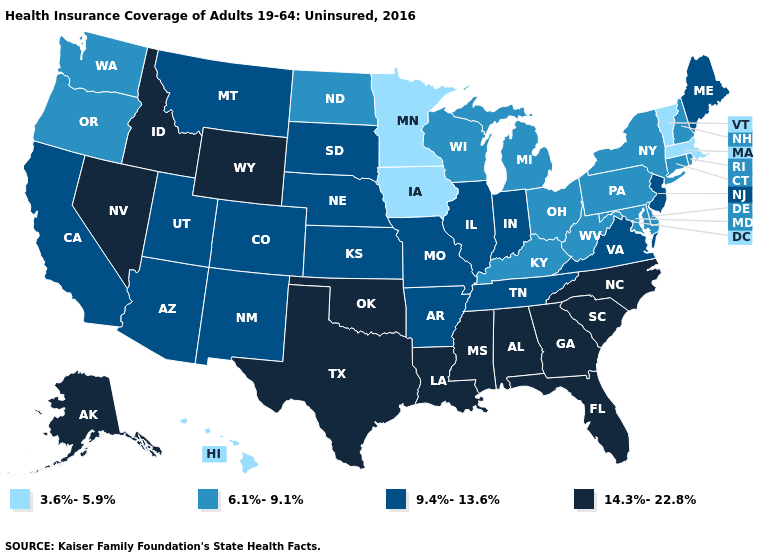What is the lowest value in the Northeast?
Give a very brief answer. 3.6%-5.9%. Name the states that have a value in the range 3.6%-5.9%?
Be succinct. Hawaii, Iowa, Massachusetts, Minnesota, Vermont. Name the states that have a value in the range 6.1%-9.1%?
Short answer required. Connecticut, Delaware, Kentucky, Maryland, Michigan, New Hampshire, New York, North Dakota, Ohio, Oregon, Pennsylvania, Rhode Island, Washington, West Virginia, Wisconsin. Is the legend a continuous bar?
Concise answer only. No. Name the states that have a value in the range 9.4%-13.6%?
Concise answer only. Arizona, Arkansas, California, Colorado, Illinois, Indiana, Kansas, Maine, Missouri, Montana, Nebraska, New Jersey, New Mexico, South Dakota, Tennessee, Utah, Virginia. What is the value of Maryland?
Answer briefly. 6.1%-9.1%. Does Georgia have a lower value than New Mexico?
Be succinct. No. What is the highest value in the USA?
Write a very short answer. 14.3%-22.8%. What is the highest value in the USA?
Quick response, please. 14.3%-22.8%. Does the first symbol in the legend represent the smallest category?
Keep it brief. Yes. Does Maryland have the lowest value in the South?
Answer briefly. Yes. Name the states that have a value in the range 14.3%-22.8%?
Be succinct. Alabama, Alaska, Florida, Georgia, Idaho, Louisiana, Mississippi, Nevada, North Carolina, Oklahoma, South Carolina, Texas, Wyoming. What is the value of Arkansas?
Quick response, please. 9.4%-13.6%. Which states have the lowest value in the USA?
Give a very brief answer. Hawaii, Iowa, Massachusetts, Minnesota, Vermont. How many symbols are there in the legend?
Give a very brief answer. 4. 